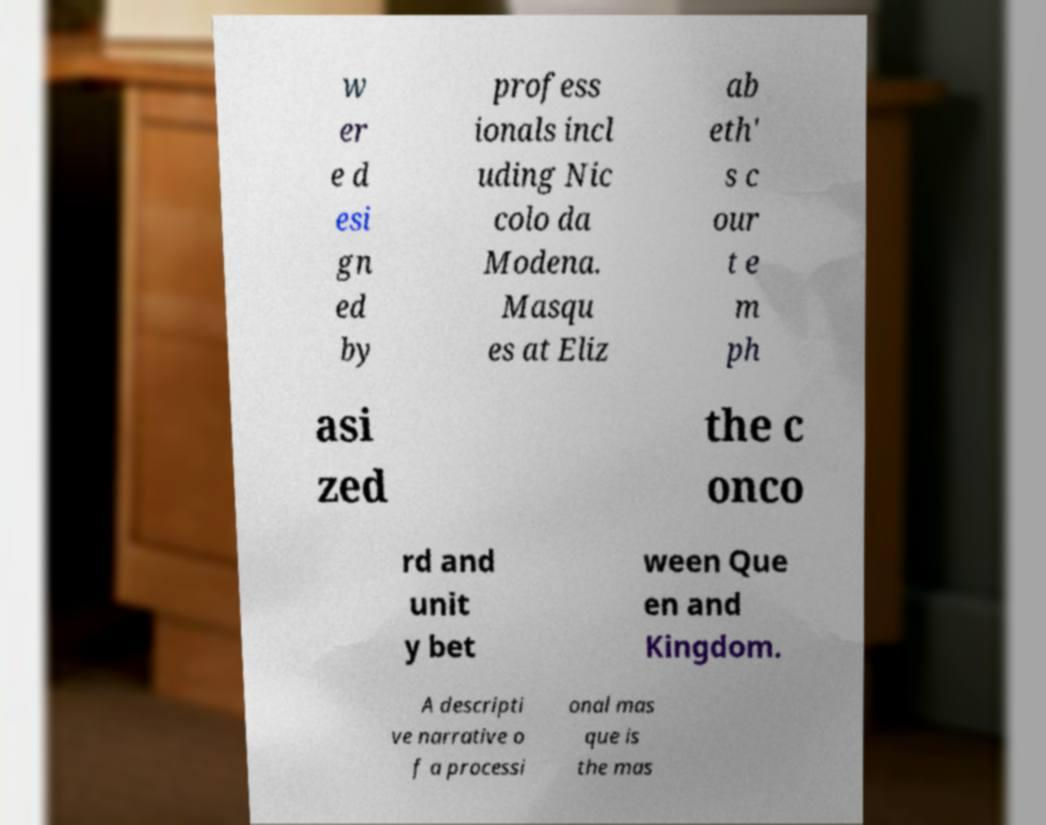Can you accurately transcribe the text from the provided image for me? w er e d esi gn ed by profess ionals incl uding Nic colo da Modena. Masqu es at Eliz ab eth' s c our t e m ph asi zed the c onco rd and unit y bet ween Que en and Kingdom. A descripti ve narrative o f a processi onal mas que is the mas 